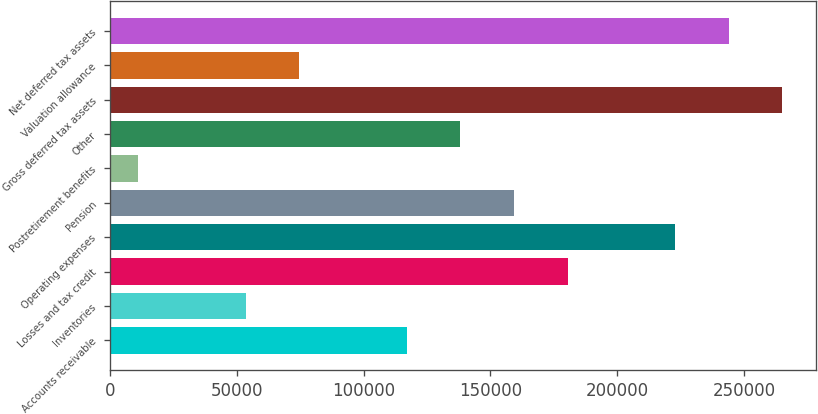Convert chart to OTSL. <chart><loc_0><loc_0><loc_500><loc_500><bar_chart><fcel>Accounts receivable<fcel>Inventories<fcel>Losses and tax credit<fcel>Operating expenses<fcel>Pension<fcel>Postretirement benefits<fcel>Other<fcel>Gross deferred tax assets<fcel>Valuation allowance<fcel>Net deferred tax assets<nl><fcel>116992<fcel>53515.2<fcel>180470<fcel>222788<fcel>159311<fcel>11197<fcel>138152<fcel>265106<fcel>74674.3<fcel>243947<nl></chart> 